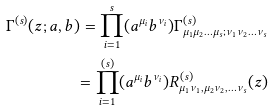<formula> <loc_0><loc_0><loc_500><loc_500>\Gamma ^ { ( s ) } ( z ; a , b ) = \prod ^ { s } _ { i = 1 } ( a ^ { \mu _ { i } } b ^ { \nu _ { i } } ) \Gamma ^ { ( s ) } _ { \mu _ { 1 } \mu _ { 2 } \dots \mu _ { s } ; \nu _ { 1 } \nu _ { 2 } \dots \nu _ { s } } \\ = \prod ^ { ( s ) } _ { i = 1 } ( a ^ { \mu _ { i } } b ^ { \nu _ { i } } ) R ^ { ( s ) } _ { \mu _ { 1 } \nu _ { 1 } , \mu _ { 2 } \nu _ { 2 } , \dots \nu _ { s } } ( z )</formula> 